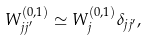Convert formula to latex. <formula><loc_0><loc_0><loc_500><loc_500>W _ { j j ^ { \prime } } ^ { \left ( 0 , 1 \right ) } \simeq W _ { j } ^ { \left ( 0 , 1 \right ) } \delta _ { j j ^ { \prime } } ,</formula> 